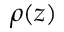Convert formula to latex. <formula><loc_0><loc_0><loc_500><loc_500>\rho ( z )</formula> 